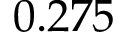<formula> <loc_0><loc_0><loc_500><loc_500>0 . 2 7 5</formula> 